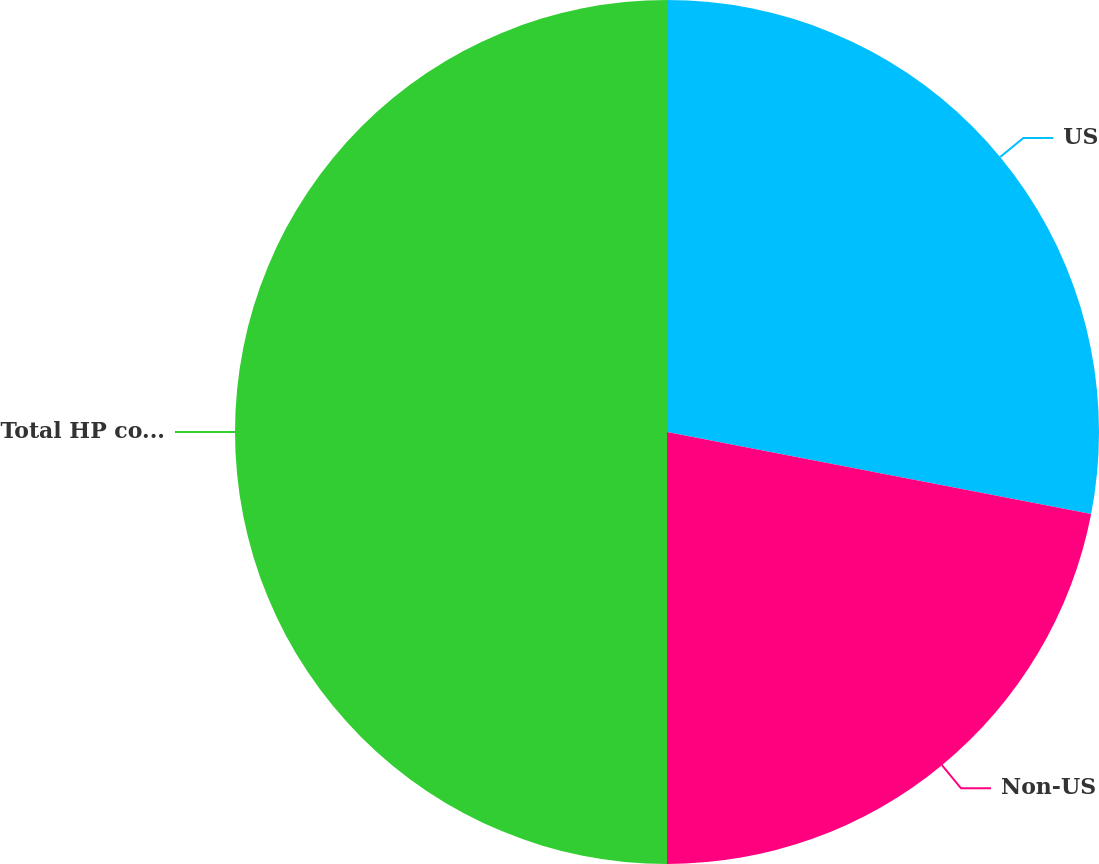Convert chart. <chart><loc_0><loc_0><loc_500><loc_500><pie_chart><fcel>US<fcel>Non-US<fcel>Total HP consolidated net<nl><fcel>28.04%<fcel>21.96%<fcel>50.0%<nl></chart> 